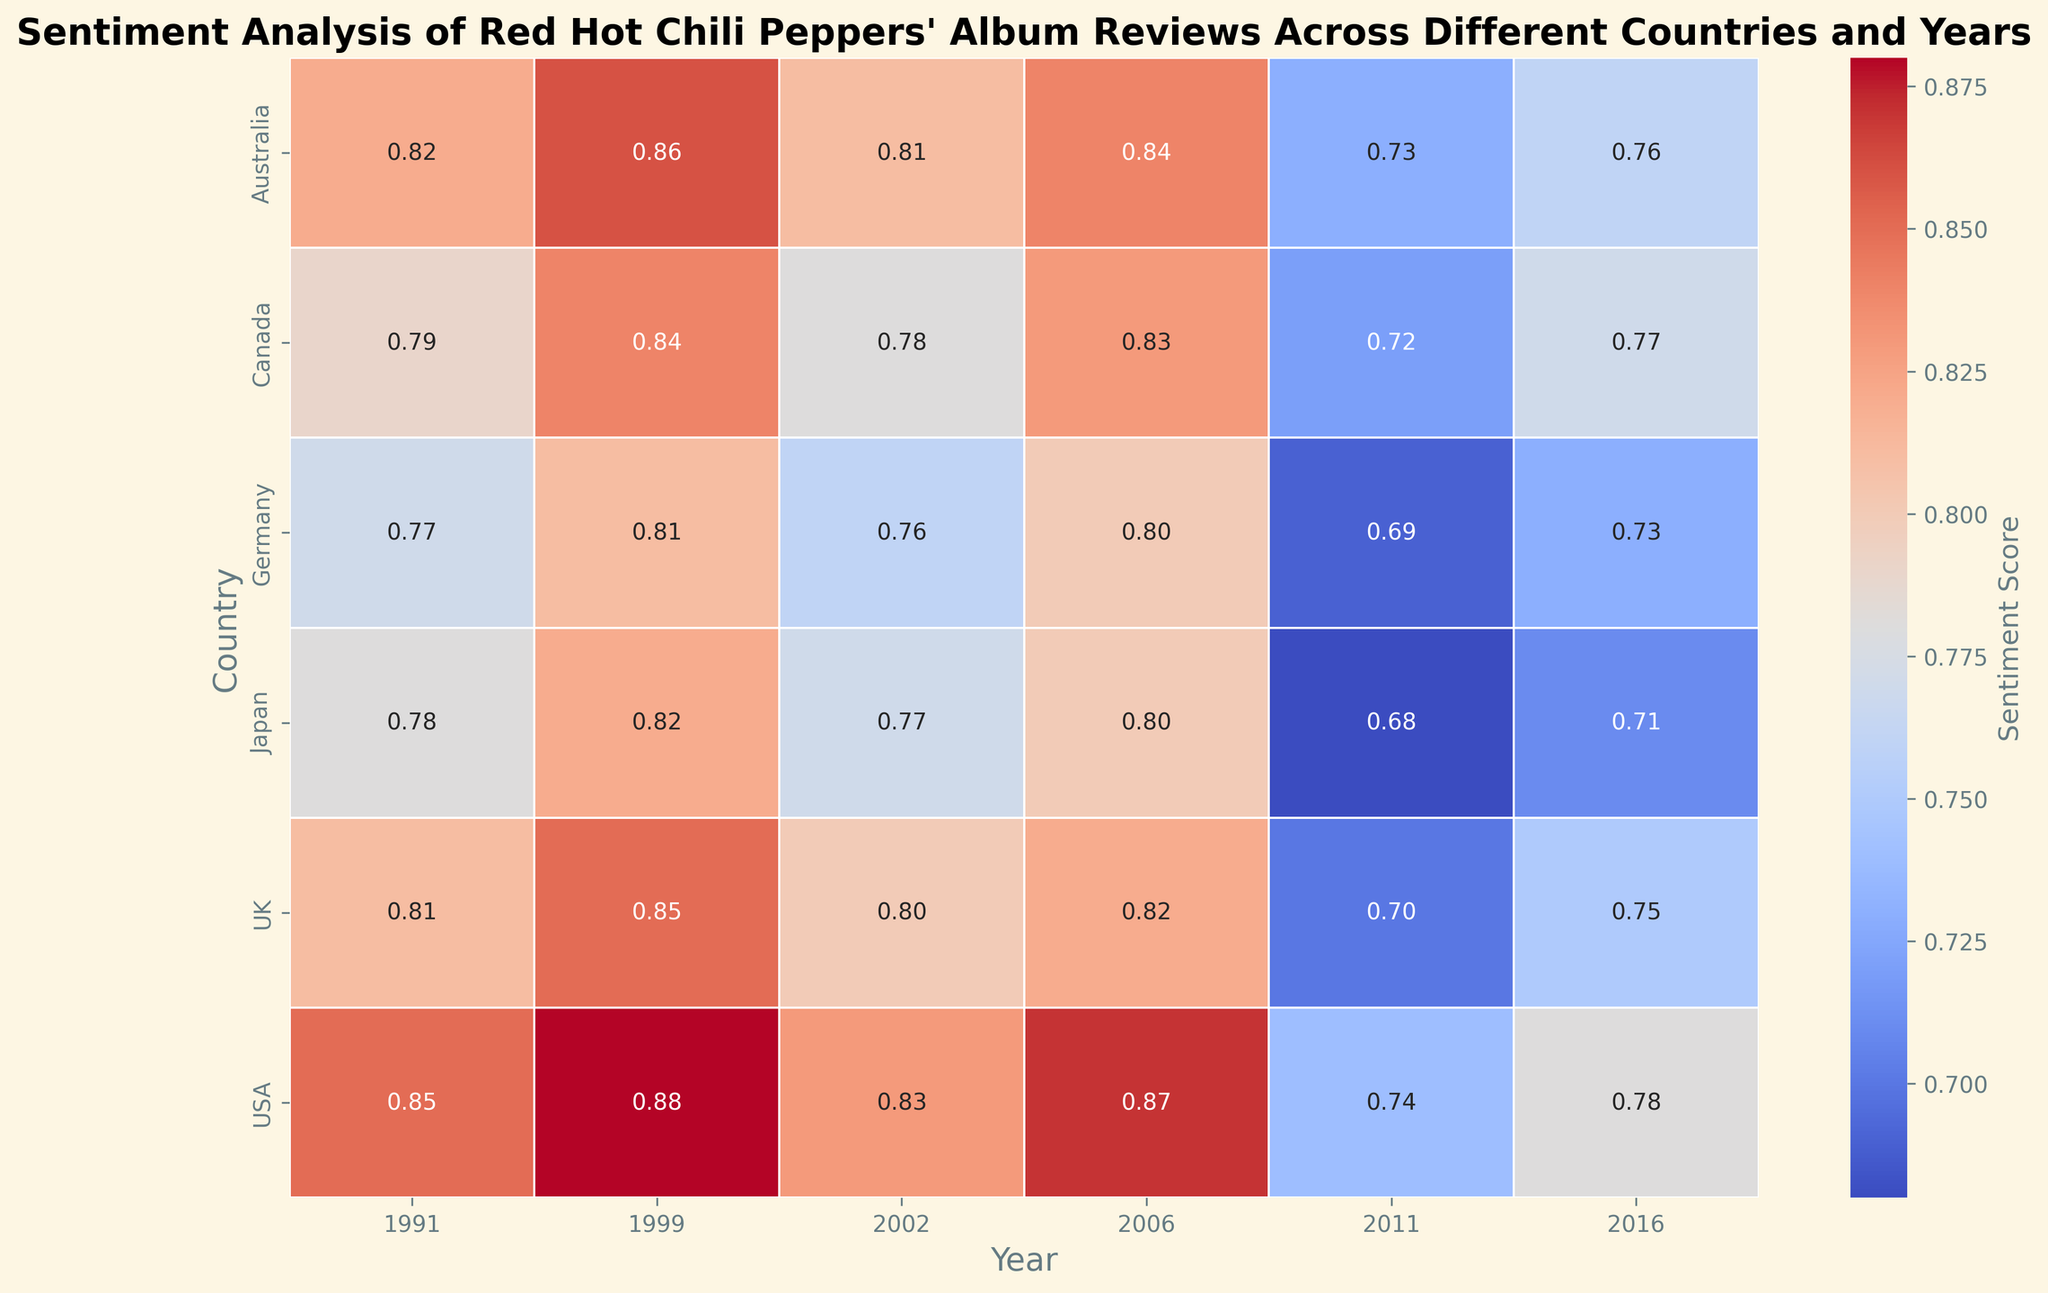What country had the highest sentiment score in 2006? To answer this, locate the 2006 column and find the cell with the highest sentiment score. The value is 0.87, and it belongs to the USA.
Answer: USA Which album received the lowest sentiment score in Japan? Identify all the sentiment scores for albums in Japan, then select the lowest value. 'I'm With You' in 2011 has a sentiment score of 0.68, which is the lowest.
Answer: I'm With You What is the average sentiment score for 'Californication' across all countries? Find the sentiment scores for 'Californication' in each country (0.88, 0.85, 0.84, 0.81, 0.86, 0.82), sum them up (5.06), and then divide by the number of countries (6). 5.06 / 6 = 0.843.
Answer: 0.843 How did sentiment scores for the album 'The Getaway' change from 2011 to 2016 in the USA? Compare the sentiment scores for the USA in 2011 (0.74) for 'I'm With You' and 2016 (0.78) for 'The Getaway'. The score increased from 0.74 to 0.78.
Answer: Increased Which year had the highest average sentiment score across all countries? Calculate the average sentiment score for each year by summing the scores in each column and dividing by the number of entries for that year. In 1999, the average is highest among the years.
Answer: 1999 Is there any country that showed a consistent increase in sentiment score from 'Blood Sugar Sex Magik' to 'The Getaway'? For each country, compare the sentiment scores across the albums 'Blood Sugar Sex Magik' (1991), 'Californication' (1999), 'By the Way' (2002), 'Stadium Arcadium' (2006), 'I'm With You' (2011), and 'The Getaway' (2016). No country shows a consistent increase in sentiment scores across all albums.
Answer: No What is the difference between the highest and lowest sentiment scores in the USA? Subtract the lowest sentiment score in the USA (0.74 for 'I'm With You', 2011) from the highest sentiment score (0.88 for 'Californication', 1999). The difference is 0.88 - 0.74 = 0.14.
Answer: 0.14 Which country has the most balanced sentiment scores across all years? To determine the most balanced sentiment scores, assess the variance of scores for each country. Australia shows the least variation, indicating the most balanced sentiment scores.
Answer: Australia In 2002, which country gave 'By the Way' the highest sentiment score, and what was it? Locate the sentiment scores for 'By the Way' in 2002 from each country and find the highest one. Australia gave it the highest score of 0.81.
Answer: Australia, 0.81 